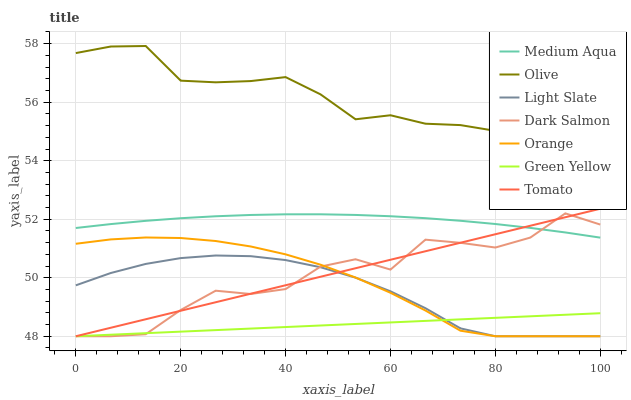Does Green Yellow have the minimum area under the curve?
Answer yes or no. Yes. Does Olive have the maximum area under the curve?
Answer yes or no. Yes. Does Light Slate have the minimum area under the curve?
Answer yes or no. No. Does Light Slate have the maximum area under the curve?
Answer yes or no. No. Is Tomato the smoothest?
Answer yes or no. Yes. Is Dark Salmon the roughest?
Answer yes or no. Yes. Is Light Slate the smoothest?
Answer yes or no. No. Is Light Slate the roughest?
Answer yes or no. No. Does Tomato have the lowest value?
Answer yes or no. Yes. Does Medium Aqua have the lowest value?
Answer yes or no. No. Does Olive have the highest value?
Answer yes or no. Yes. Does Light Slate have the highest value?
Answer yes or no. No. Is Light Slate less than Medium Aqua?
Answer yes or no. Yes. Is Olive greater than Medium Aqua?
Answer yes or no. Yes. Does Light Slate intersect Orange?
Answer yes or no. Yes. Is Light Slate less than Orange?
Answer yes or no. No. Is Light Slate greater than Orange?
Answer yes or no. No. Does Light Slate intersect Medium Aqua?
Answer yes or no. No. 